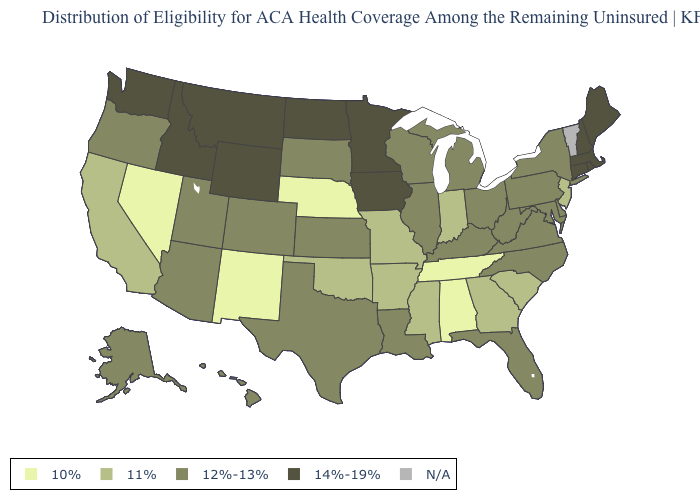Among the states that border Arkansas , which have the highest value?
Be succinct. Louisiana, Texas. Does the map have missing data?
Be succinct. Yes. Among the states that border Oklahoma , does Texas have the highest value?
Write a very short answer. Yes. What is the value of Kansas?
Write a very short answer. 12%-13%. Among the states that border Arizona , which have the lowest value?
Answer briefly. Nevada, New Mexico. What is the value of Alabama?
Keep it brief. 10%. Name the states that have a value in the range N/A?
Be succinct. Vermont. Name the states that have a value in the range 10%?
Quick response, please. Alabama, Nebraska, Nevada, New Mexico, Tennessee. Which states have the lowest value in the USA?
Short answer required. Alabama, Nebraska, Nevada, New Mexico, Tennessee. Name the states that have a value in the range 11%?
Keep it brief. Arkansas, California, Georgia, Indiana, Mississippi, Missouri, New Jersey, Oklahoma, South Carolina. What is the lowest value in states that border Indiana?
Be succinct. 12%-13%. Among the states that border Montana , does Wyoming have the lowest value?
Write a very short answer. No. Does the first symbol in the legend represent the smallest category?
Answer briefly. Yes. 